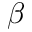<formula> <loc_0><loc_0><loc_500><loc_500>\beta</formula> 